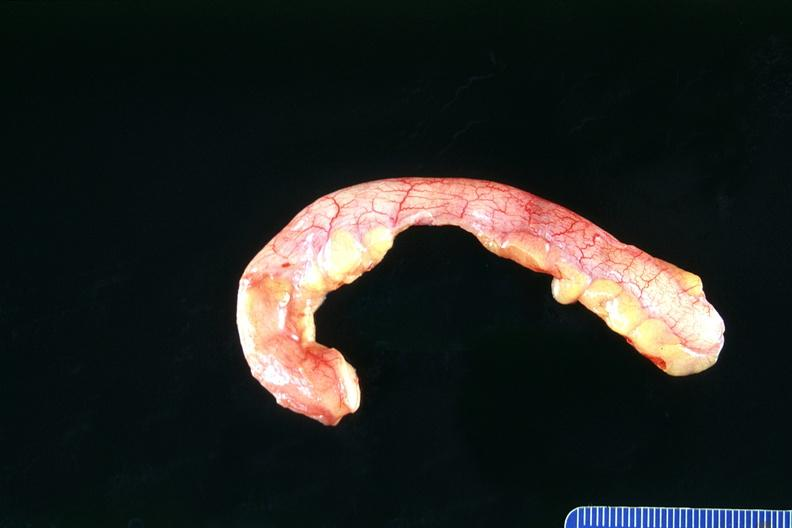s gastrointestinal present?
Answer the question using a single word or phrase. Yes 